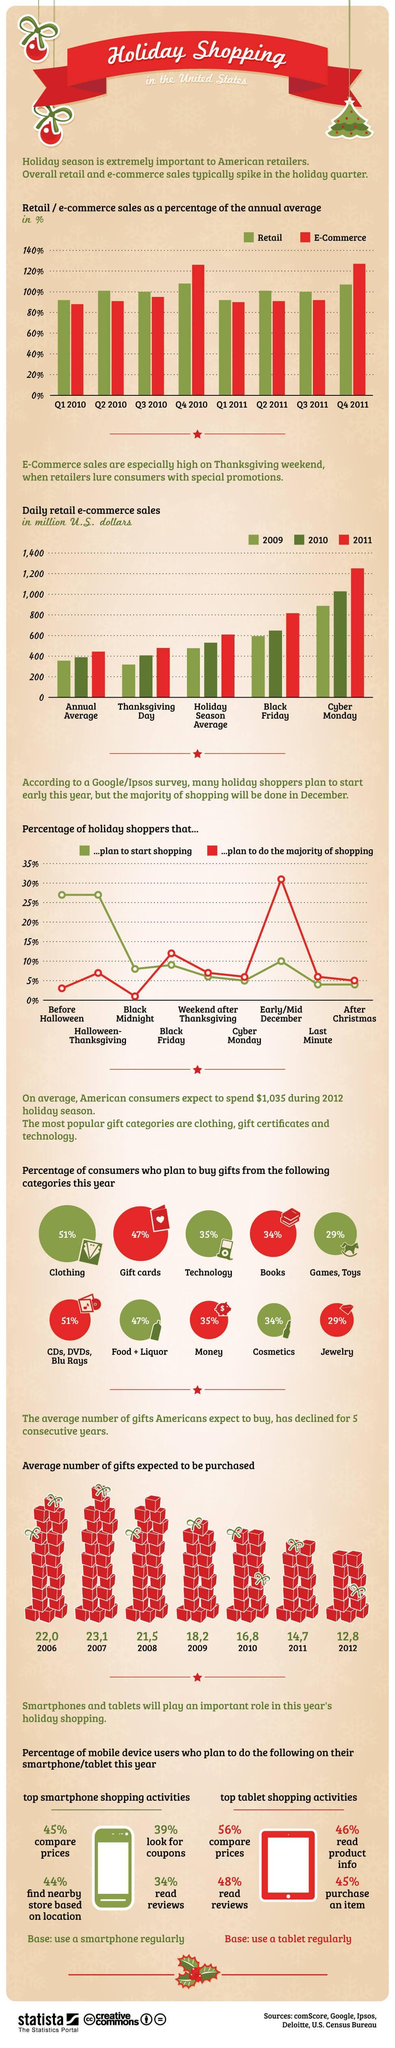What percentage of consumers plan to buy Cosmetics?
Answer the question with a short phrase. 34% In which year was the Black Friday sales just above 800? 2011 The lowest Thanksgiving Day sales was recorded in which year? 2009 In Q4 2011, which sales showed higher percentage - retail or E-commerce? E-commerce How much was the Thanksgiving day retail e-commerce sales(in million US Dollars) of 2010? 400 How much was the sales percentage of retail in Q3 2011? 100% In which quarter of 2010 did E-commerce sales go above retail sales percentage? Q4 What percentage of consumers plan to buy Games and Toys? 29% What percentage of holiday shoppers plan to start shopping in early/mid December? 10 